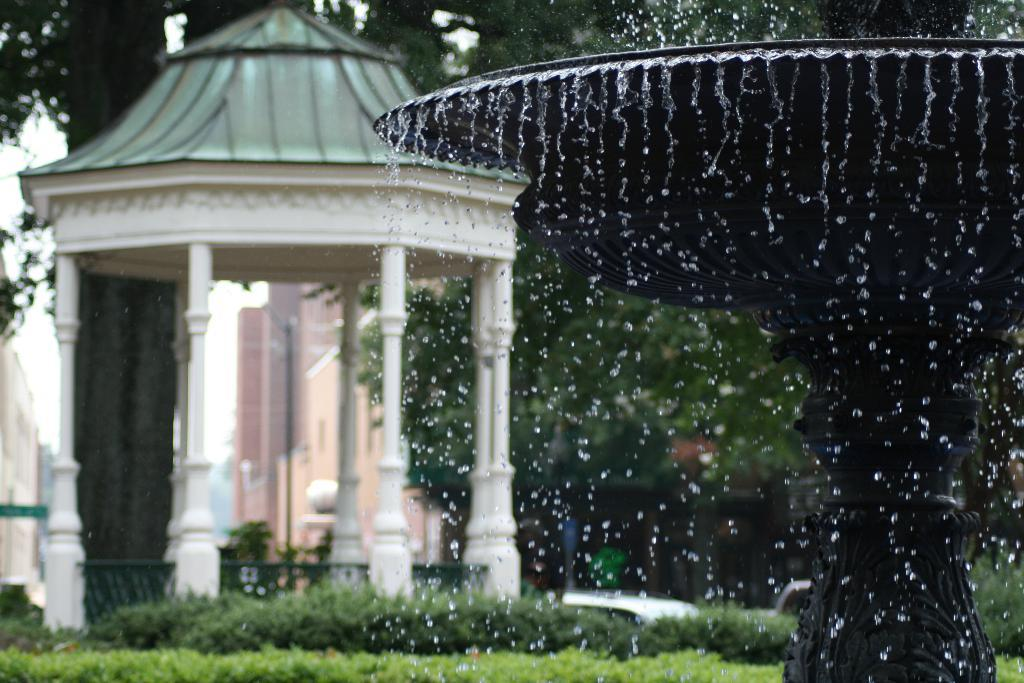What natural feature is located on the right side of the image? There is a waterfall on the right side of the image. What type of structure is on the left side of the image? There is a construction in white color on the left side of the image. What type of vegetation is at the bottom of the image? There are bushes at the bottom of the image. What type of stem can be seen growing from the waterfall in the image? There is no stem growing from the waterfall in the image. What offer is being made by the construction in the image? The construction in the image is not making any offer; it is a stationary structure. 